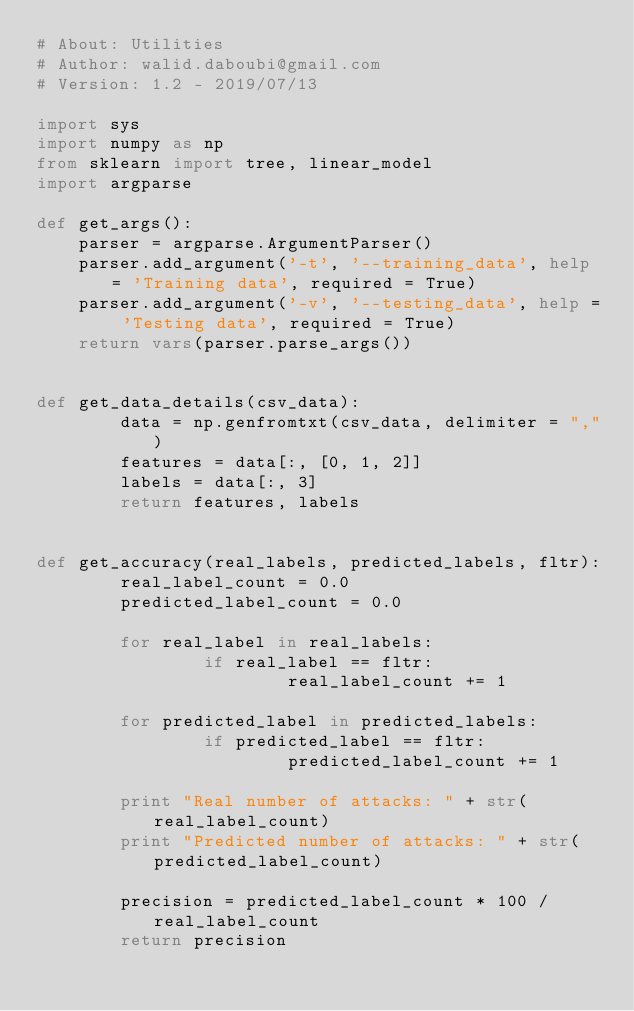Convert code to text. <code><loc_0><loc_0><loc_500><loc_500><_Python_># About: Utilities
# Author: walid.daboubi@gmail.com
# Version: 1.2 - 2019/07/13

import sys
import numpy as np
from sklearn import tree, linear_model
import argparse

def get_args():
    parser = argparse.ArgumentParser()
    parser.add_argument('-t', '--training_data', help = 'Training data', required = True)
    parser.add_argument('-v', '--testing_data', help = 'Testing data', required = True)
    return vars(parser.parse_args())


def get_data_details(csv_data):
        data = np.genfromtxt(csv_data, delimiter = ",")
        features = data[:, [0, 1, 2]]
        labels = data[:, 3]
        return features, labels


def get_accuracy(real_labels, predicted_labels, fltr):
        real_label_count = 0.0
        predicted_label_count = 0.0

        for real_label in real_labels:
                if real_label == fltr:
                        real_label_count += 1

        for predicted_label in predicted_labels:
                if predicted_label == fltr:
                        predicted_label_count += 1

        print "Real number of attacks: " + str(real_label_count)
        print "Predicted number of attacks: " + str(predicted_label_count)

        precision = predicted_label_count * 100 / real_label_count
        return precision
</code> 